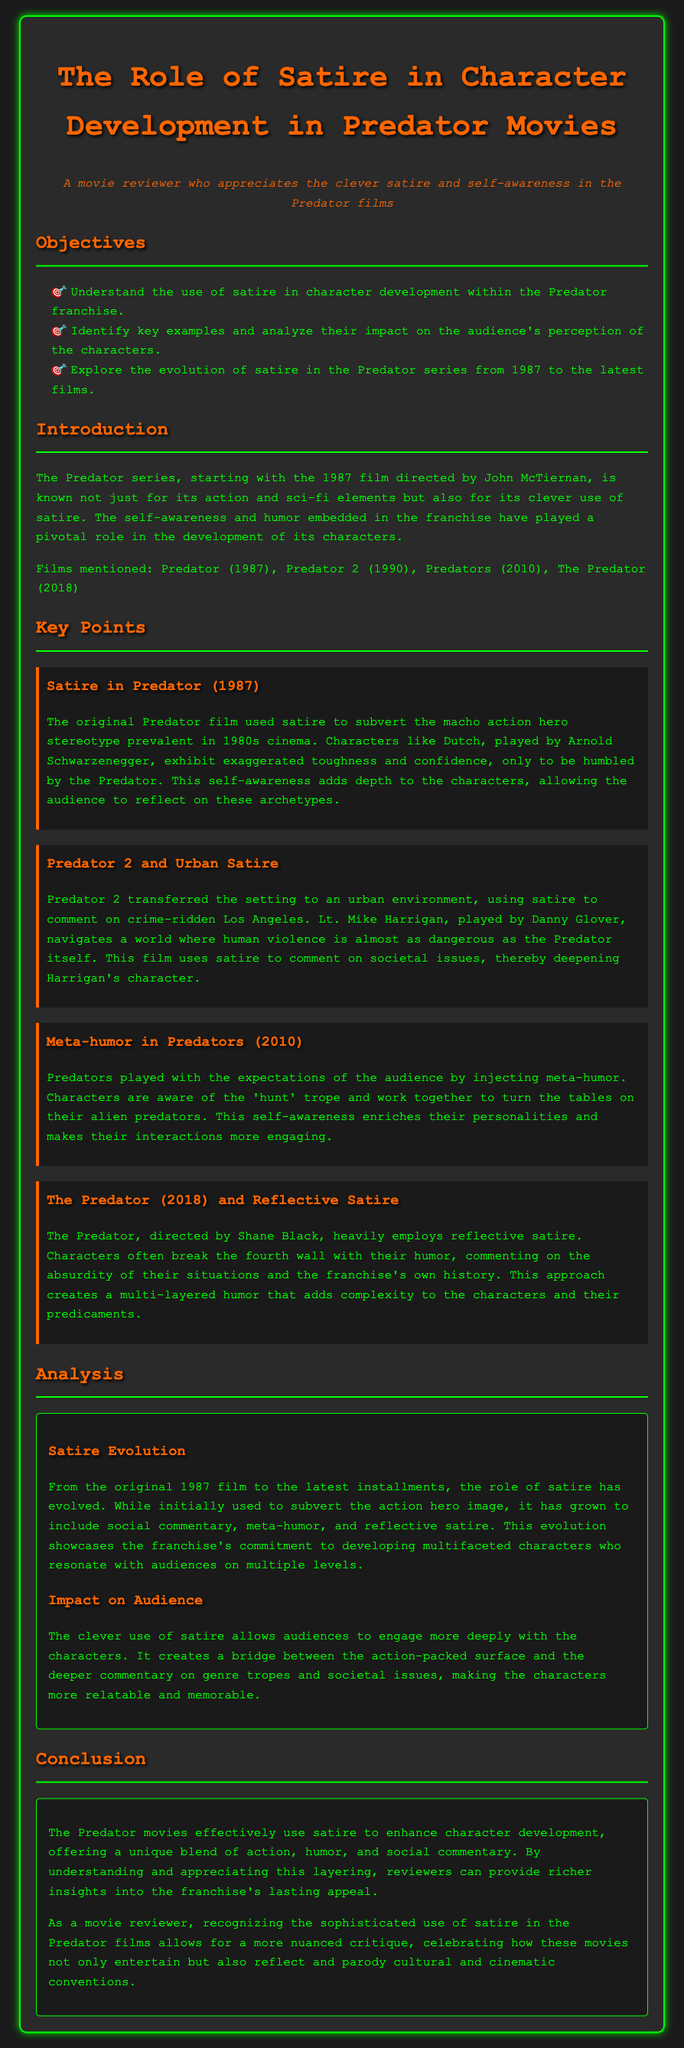What are the objectives of the lesson plan? The objectives outline what the lesson aims to achieve, which include understanding satire in character development and analyzing its impact.
Answer: Understand the use of satire in character development within the Predator franchise Which film initiated the Predator series? The document states that the Predator series started with a specific film in 1987.
Answer: Predator (1987) Who directed the original Predator film? The lesson plan credits a specific director for the original film, providing insight into its creative vision.
Answer: John McTiernan What is a key theme explored in Predator 2? The document identifies a main theme in Predator 2 that relates to its urban setting and character development.
Answer: Urban satire How does Predators (2010) utilize meta-humor? The lesson plan describes how Predators plays with audience expectations through a specific type of humor.
Answer: Injecting meta-humor What aspect of satire does The Predator (2018) focus on? The document highlights a unique approach to satire employed in The Predator that comments on its own history.
Answer: Reflective satire What is the total number of films mentioned in the lesson plan? The document specifies how many films from the franchise are referred to within the content.
Answer: Four What styles of satire are mentioned throughout the series? The lesson plan details different styles of satire that evolved across the films, requiring a synthesis of information.
Answer: Subverting action hero image, social commentary, meta-humor, reflective satire What is the conclusion regarding the role of satire in the Predator series? The document summarizes the overall significance of satire in the character development and enjoyment of the franchise.
Answer: Enhance character development 